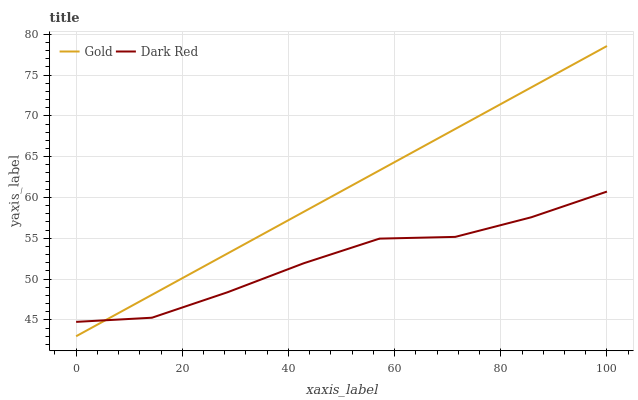Does Dark Red have the minimum area under the curve?
Answer yes or no. Yes. Does Gold have the maximum area under the curve?
Answer yes or no. Yes. Does Gold have the minimum area under the curve?
Answer yes or no. No. Is Gold the smoothest?
Answer yes or no. Yes. Is Dark Red the roughest?
Answer yes or no. Yes. Is Gold the roughest?
Answer yes or no. No. 